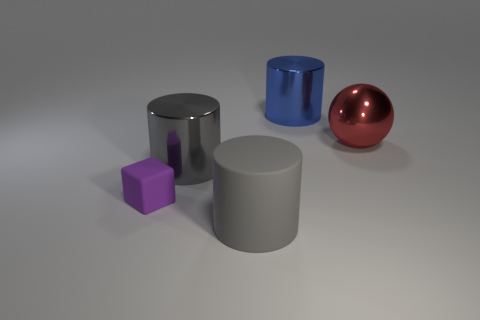Add 2 gray cylinders. How many objects exist? 7 Subtract all cylinders. How many objects are left? 2 Subtract all blue rubber balls. Subtract all blue shiny cylinders. How many objects are left? 4 Add 3 cylinders. How many cylinders are left? 6 Add 1 shiny cylinders. How many shiny cylinders exist? 3 Subtract 2 gray cylinders. How many objects are left? 3 